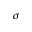Convert formula to latex. <formula><loc_0><loc_0><loc_500><loc_500>\sigma</formula> 